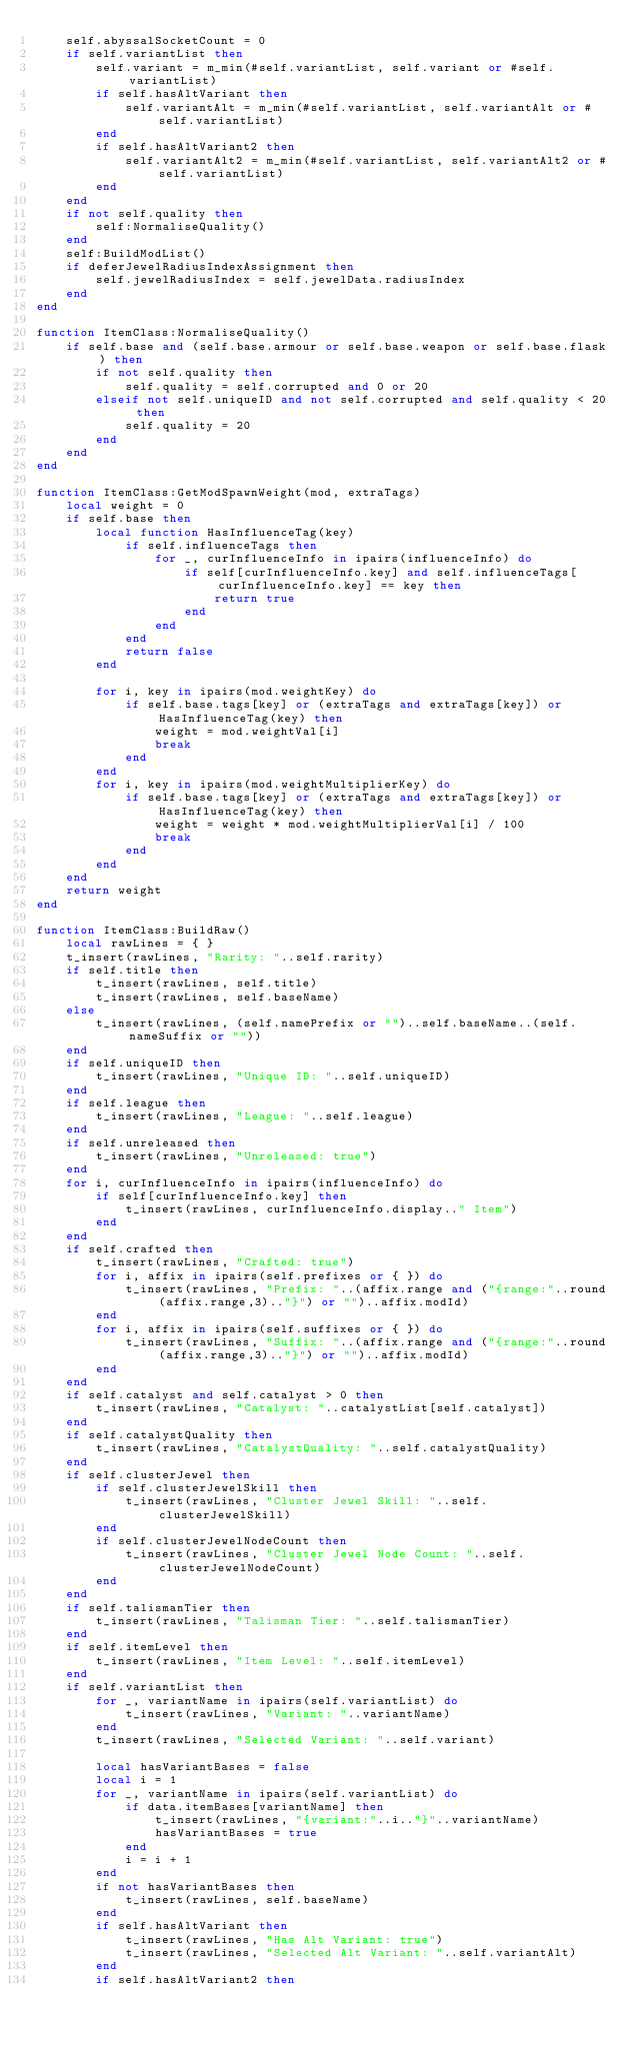<code> <loc_0><loc_0><loc_500><loc_500><_Lua_>	self.abyssalSocketCount = 0
	if self.variantList then
		self.variant = m_min(#self.variantList, self.variant or #self.variantList)
		if self.hasAltVariant then
			self.variantAlt = m_min(#self.variantList, self.variantAlt or #self.variantList)
		end
		if self.hasAltVariant2 then
			self.variantAlt2 = m_min(#self.variantList, self.variantAlt2 or #self.variantList)
		end
	end
	if not self.quality then
		self:NormaliseQuality()
	end
	self:BuildModList()
	if deferJewelRadiusIndexAssignment then
		self.jewelRadiusIndex = self.jewelData.radiusIndex
	end
end

function ItemClass:NormaliseQuality()
	if self.base and (self.base.armour or self.base.weapon or self.base.flask) then
		if not self.quality then
			self.quality = self.corrupted and 0 or 20 
		elseif not self.uniqueID and not self.corrupted and self.quality < 20 then
			self.quality = 20
		end
	end	
end

function ItemClass:GetModSpawnWeight(mod, extraTags)
	local weight = 0
	if self.base then
		local function HasInfluenceTag(key)
			if self.influenceTags then
				for _, curInfluenceInfo in ipairs(influenceInfo) do
					if self[curInfluenceInfo.key] and self.influenceTags[curInfluenceInfo.key] == key then
						return true
					end
				end
			end
			return false
		end

		for i, key in ipairs(mod.weightKey) do
			if self.base.tags[key] or (extraTags and extraTags[key]) or HasInfluenceTag(key) then
				weight = mod.weightVal[i]
				break
			end
		end
		for i, key in ipairs(mod.weightMultiplierKey) do
			if self.base.tags[key] or (extraTags and extraTags[key]) or HasInfluenceTag(key) then
				weight = weight * mod.weightMultiplierVal[i] / 100
				break
			end
		end
	end
	return weight
end

function ItemClass:BuildRaw()
	local rawLines = { }
	t_insert(rawLines, "Rarity: "..self.rarity)
	if self.title then
		t_insert(rawLines, self.title)
		t_insert(rawLines, self.baseName)
	else
		t_insert(rawLines, (self.namePrefix or "")..self.baseName..(self.nameSuffix or ""))
	end
	if self.uniqueID then
		t_insert(rawLines, "Unique ID: "..self.uniqueID)
	end
	if self.league then
		t_insert(rawLines, "League: "..self.league)
	end
	if self.unreleased then
		t_insert(rawLines, "Unreleased: true")
	end
	for i, curInfluenceInfo in ipairs(influenceInfo) do
		if self[curInfluenceInfo.key] then
			t_insert(rawLines, curInfluenceInfo.display.." Item")
		end
	end
	if self.crafted then
		t_insert(rawLines, "Crafted: true")
		for i, affix in ipairs(self.prefixes or { }) do
			t_insert(rawLines, "Prefix: "..(affix.range and ("{range:"..round(affix.range,3).."}") or "")..affix.modId)
		end
		for i, affix in ipairs(self.suffixes or { }) do
			t_insert(rawLines, "Suffix: "..(affix.range and ("{range:"..round(affix.range,3).."}") or "")..affix.modId)
		end
	end
	if self.catalyst and self.catalyst > 0 then
		t_insert(rawLines, "Catalyst: "..catalystList[self.catalyst])
	end
	if self.catalystQuality then
		t_insert(rawLines, "CatalystQuality: "..self.catalystQuality)
	end
	if self.clusterJewel then
		if self.clusterJewelSkill then
			t_insert(rawLines, "Cluster Jewel Skill: "..self.clusterJewelSkill)
		end
		if self.clusterJewelNodeCount then
			t_insert(rawLines, "Cluster Jewel Node Count: "..self.clusterJewelNodeCount)
		end
	end
	if self.talismanTier then
		t_insert(rawLines, "Talisman Tier: "..self.talismanTier)
	end
	if self.itemLevel then
		t_insert(rawLines, "Item Level: "..self.itemLevel)
	end
	if self.variantList then
		for _, variantName in ipairs(self.variantList) do
			t_insert(rawLines, "Variant: "..variantName)
		end
		t_insert(rawLines, "Selected Variant: "..self.variant)

		local hasVariantBases = false
		local i = 1
		for _, variantName in ipairs(self.variantList) do
			if data.itemBases[variantName] then
				t_insert(rawLines, "{variant:"..i.."}"..variantName)
				hasVariantBases = true
			end
			i = i + 1
		end
		if not hasVariantBases then
			t_insert(rawLines, self.baseName)
		end
		if self.hasAltVariant then
			t_insert(rawLines, "Has Alt Variant: true")
			t_insert(rawLines, "Selected Alt Variant: "..self.variantAlt)
		end
		if self.hasAltVariant2 then</code> 